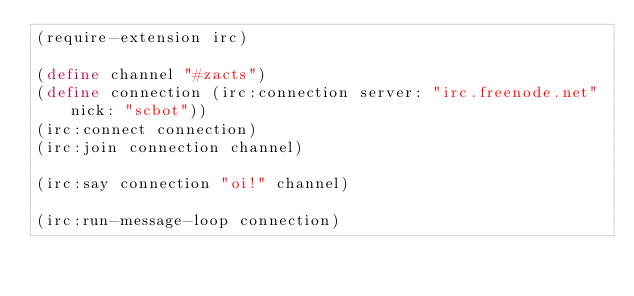<code> <loc_0><loc_0><loc_500><loc_500><_Scheme_>(require-extension irc)

(define channel "#zacts")
(define connection (irc:connection server: "irc.freenode.net" nick: "scbot"))
(irc:connect connection)
(irc:join connection channel)

(irc:say connection "oi!" channel)

(irc:run-message-loop connection)
</code> 